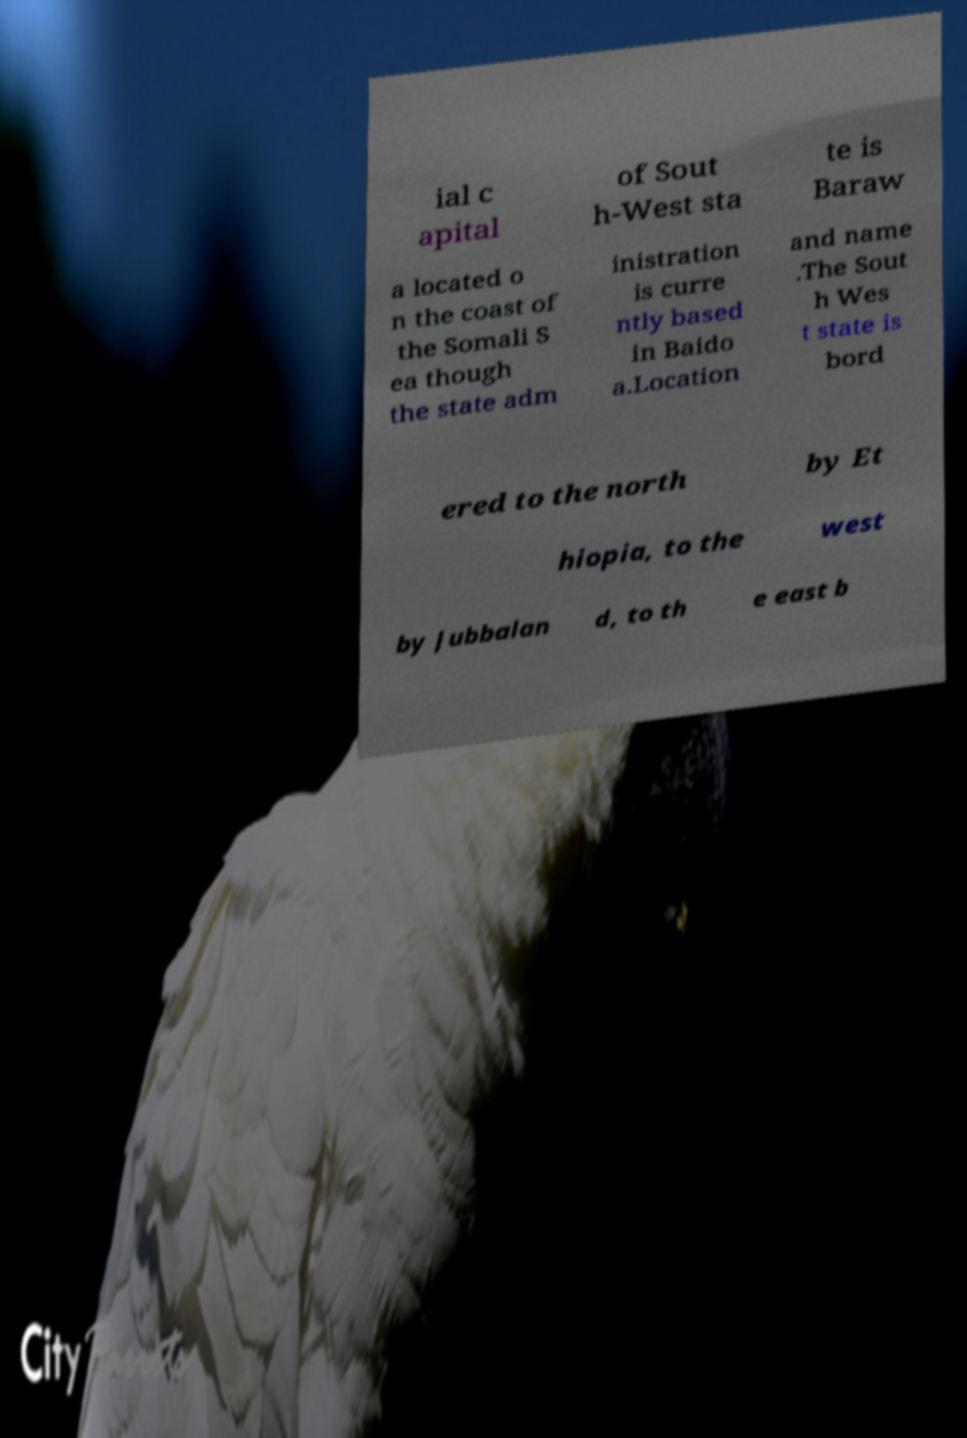Can you accurately transcribe the text from the provided image for me? ial c apital of Sout h-West sta te is Baraw a located o n the coast of the Somali S ea though the state adm inistration is curre ntly based in Baido a.Location and name .The Sout h Wes t state is bord ered to the north by Et hiopia, to the west by Jubbalan d, to th e east b 